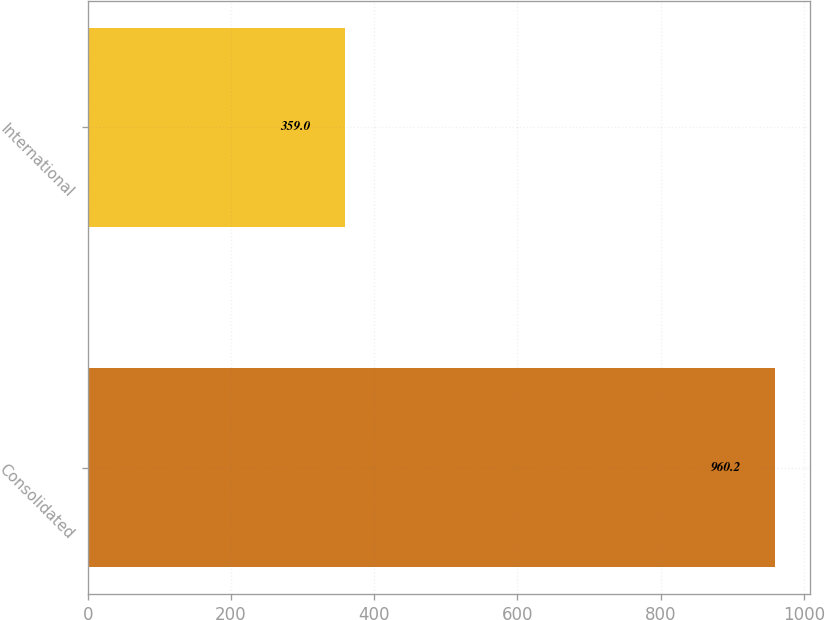Convert chart. <chart><loc_0><loc_0><loc_500><loc_500><bar_chart><fcel>Consolidated<fcel>International<nl><fcel>960.2<fcel>359<nl></chart> 